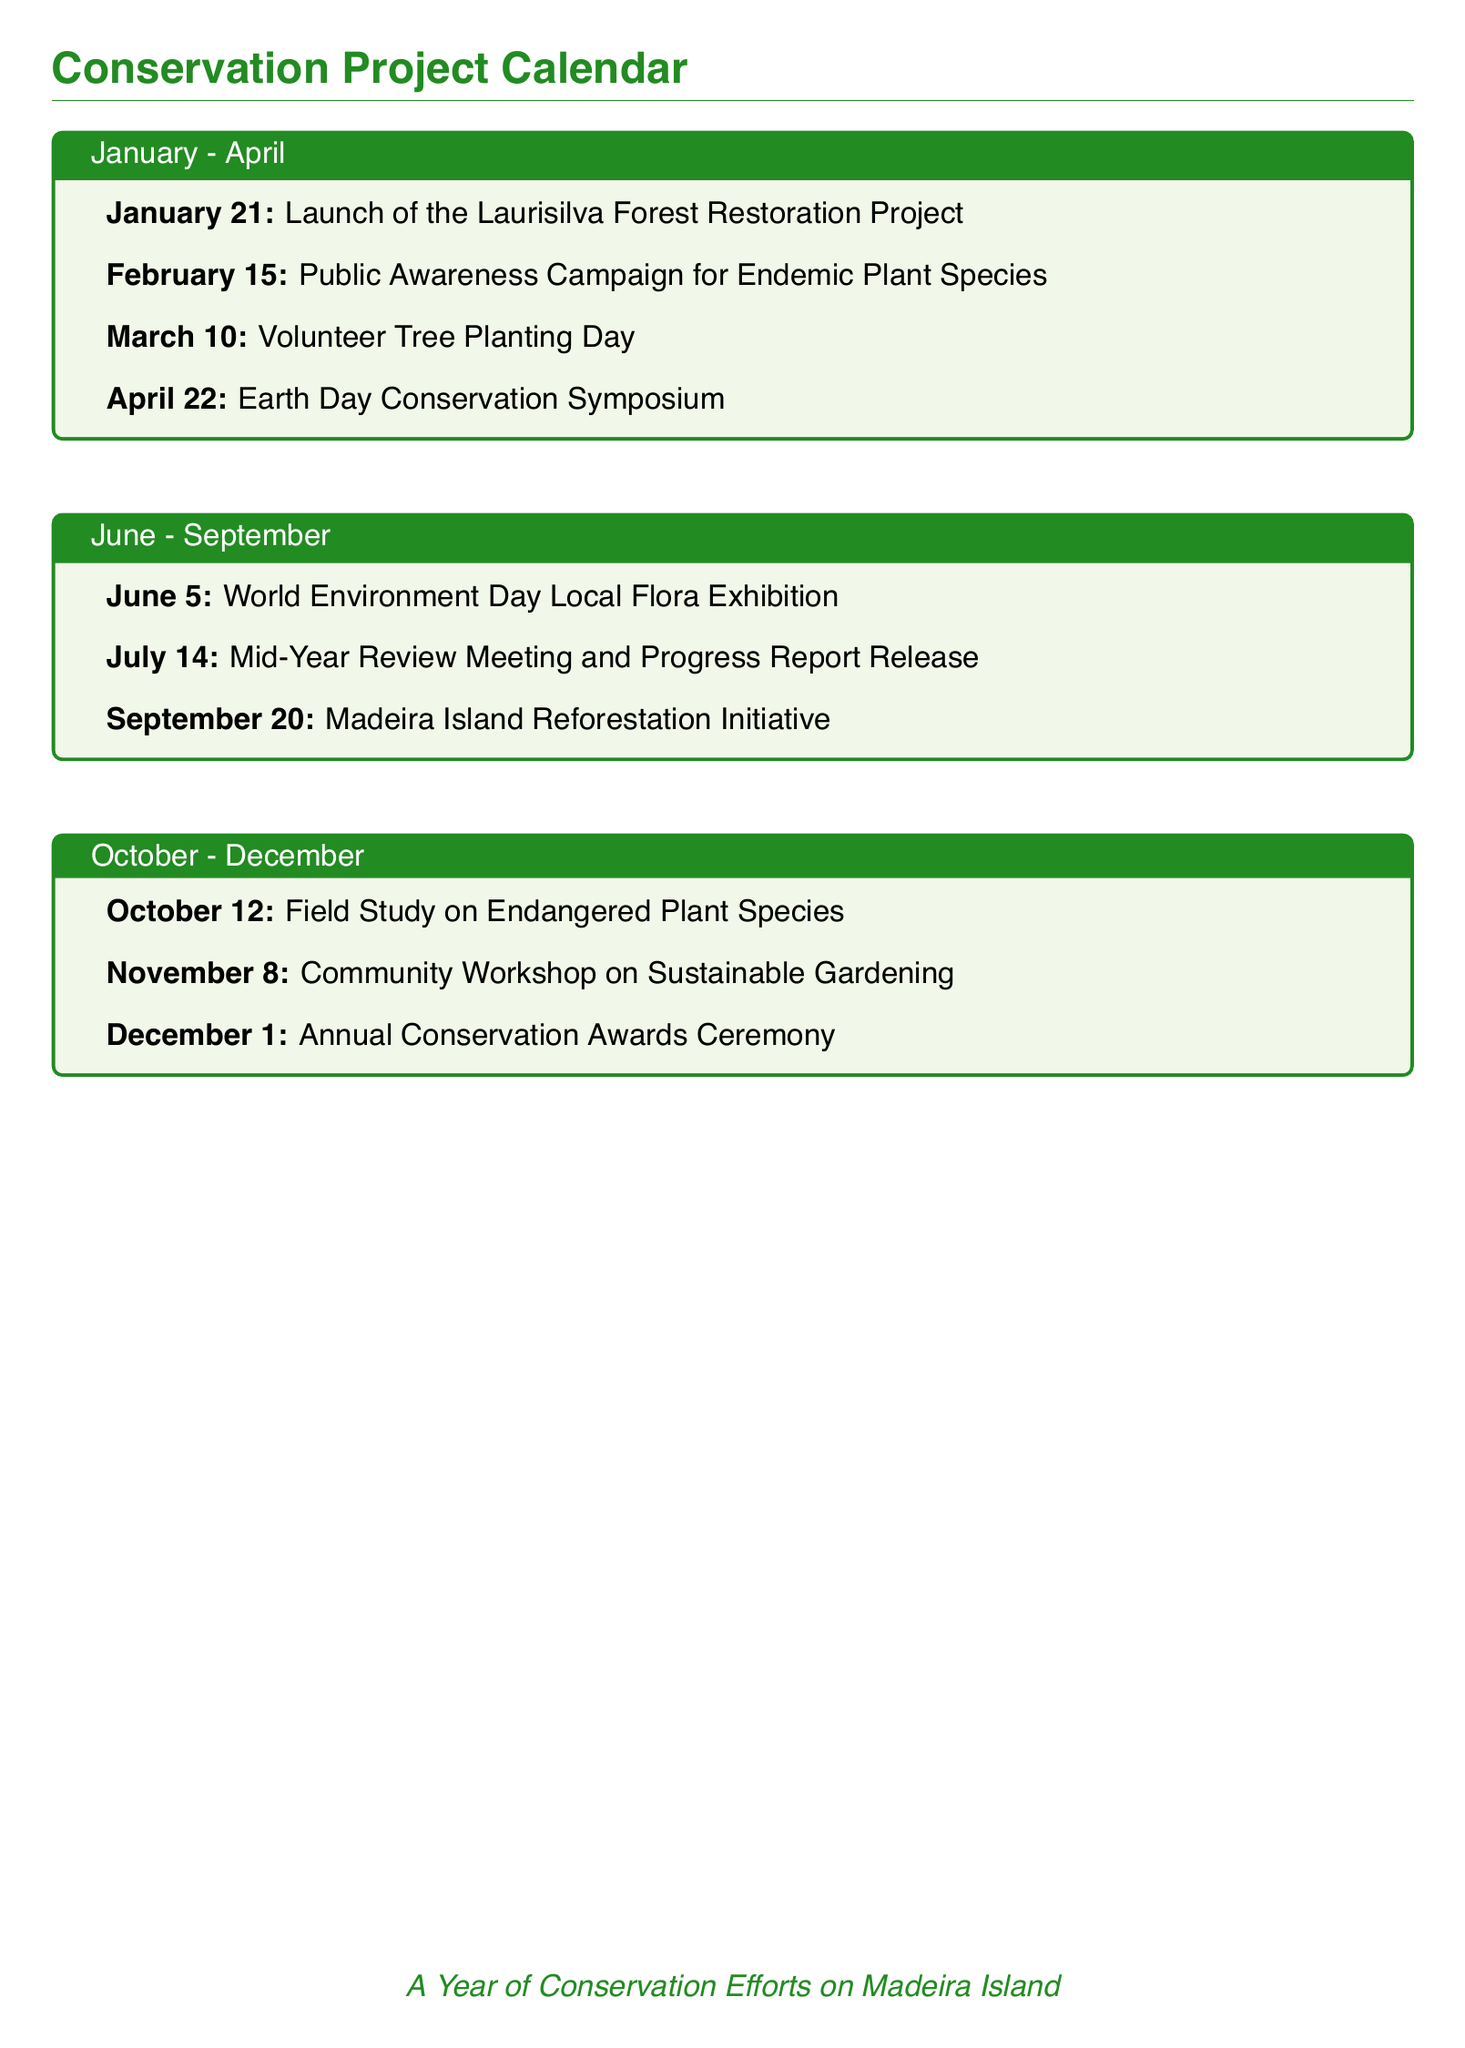What is the date of the Laurisilva Forest Restoration Project launch? The document specifies that the launch is on January 21.
Answer: January 21 What event is scheduled for March 10? The document mentions that March 10 is designated as Volunteer Tree Planting Day.
Answer: Volunteer Tree Planting Day How many events are listed in the June to September section? Upon counting the listed events, there are three mentioned in that section.
Answer: 3 What day is Earth Day Conservation Symposium held? The document shows that the symposium is on April 22, which is Earth Day.
Answer: April 22 Which month contains the Community Workshop on Sustainable Gardening? The document states that this workshop is set for November.
Answer: November When is the mid-year review meeting scheduled? The document specifies that the meeting takes place on July 14.
Answer: July 14 What is the significance of October 12 in the calendar? The calendar indicates that a Field Study on Endangered Plant Species occurs on this date.
Answer: Field Study on Endangered Plant Species What event occurs on December 1? According to the document, this date marks the Annual Conservation Awards Ceremony.
Answer: Annual Conservation Awards Ceremony Which event is related to the local flora in June? The document lists World Environment Day Local Flora Exhibition as the event.
Answer: World Environment Day Local Flora Exhibition 